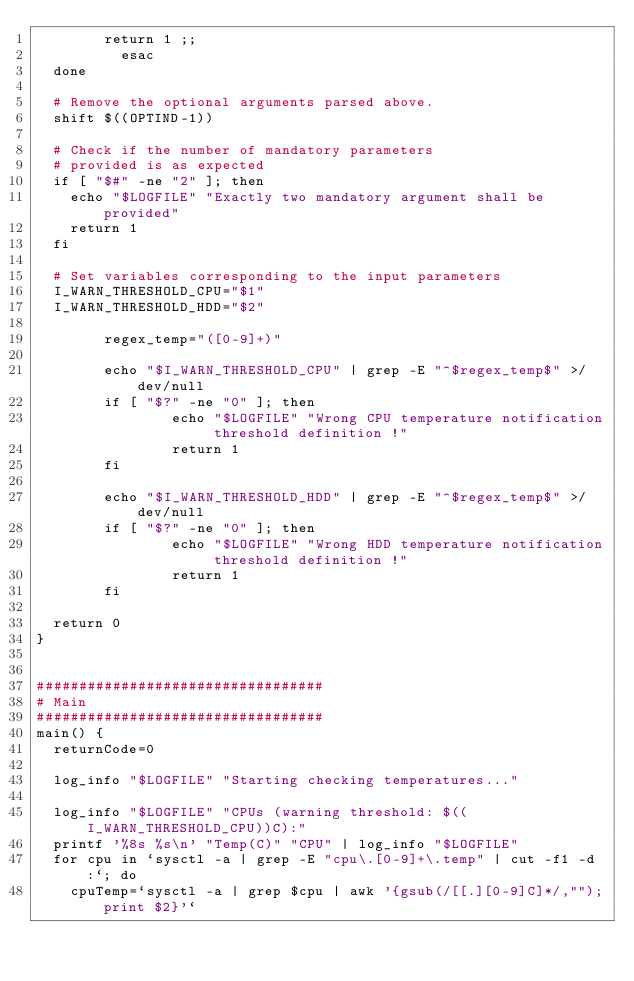Convert code to text. <code><loc_0><loc_0><loc_500><loc_500><_Bash_>				return 1 ;;
        	esac
	done

	# Remove the optional arguments parsed above.
	shift $((OPTIND-1))
	
	# Check if the number of mandatory parameters 
	# provided is as expected 
	if [ "$#" -ne "2" ]; then
		echo "$LOGFILE" "Exactly two mandatory argument shall be provided"
		return 1
	fi

	# Set variables corresponding to the input parameters
	I_WARN_THRESHOLD_CPU="$1"
	I_WARN_THRESHOLD_HDD="$2"

        regex_temp="([0-9]+)"

        echo "$I_WARN_THRESHOLD_CPU" | grep -E "^$regex_temp$" >/dev/null
        if [ "$?" -ne "0" ]; then
                echo "$LOGFILE" "Wrong CPU temperature notification threshold definition !"
                return 1
        fi

        echo "$I_WARN_THRESHOLD_HDD" | grep -E "^$regex_temp$" >/dev/null
        if [ "$?" -ne "0" ]; then
                echo "$LOGFILE" "Wrong HDD temperature notification threshold definition !"
                return 1
        fi

	return 0
}


##################################
# Main
##################################
main() {
	returnCode=0
	
	log_info "$LOGFILE" "Starting checking temperatures..."
	
	log_info "$LOGFILE" "CPUs (warning threshold: $((I_WARN_THRESHOLD_CPU))C):"
	printf '%8s %s\n' "Temp(C)" "CPU" | log_info "$LOGFILE"
	for cpu in `sysctl -a | grep -E "cpu\.[0-9]+\.temp" | cut -f1 -d:`; do 
		cpuTemp=`sysctl -a | grep $cpu | awk '{gsub(/[[.][0-9]C]*/,"");print $2}'` </code> 